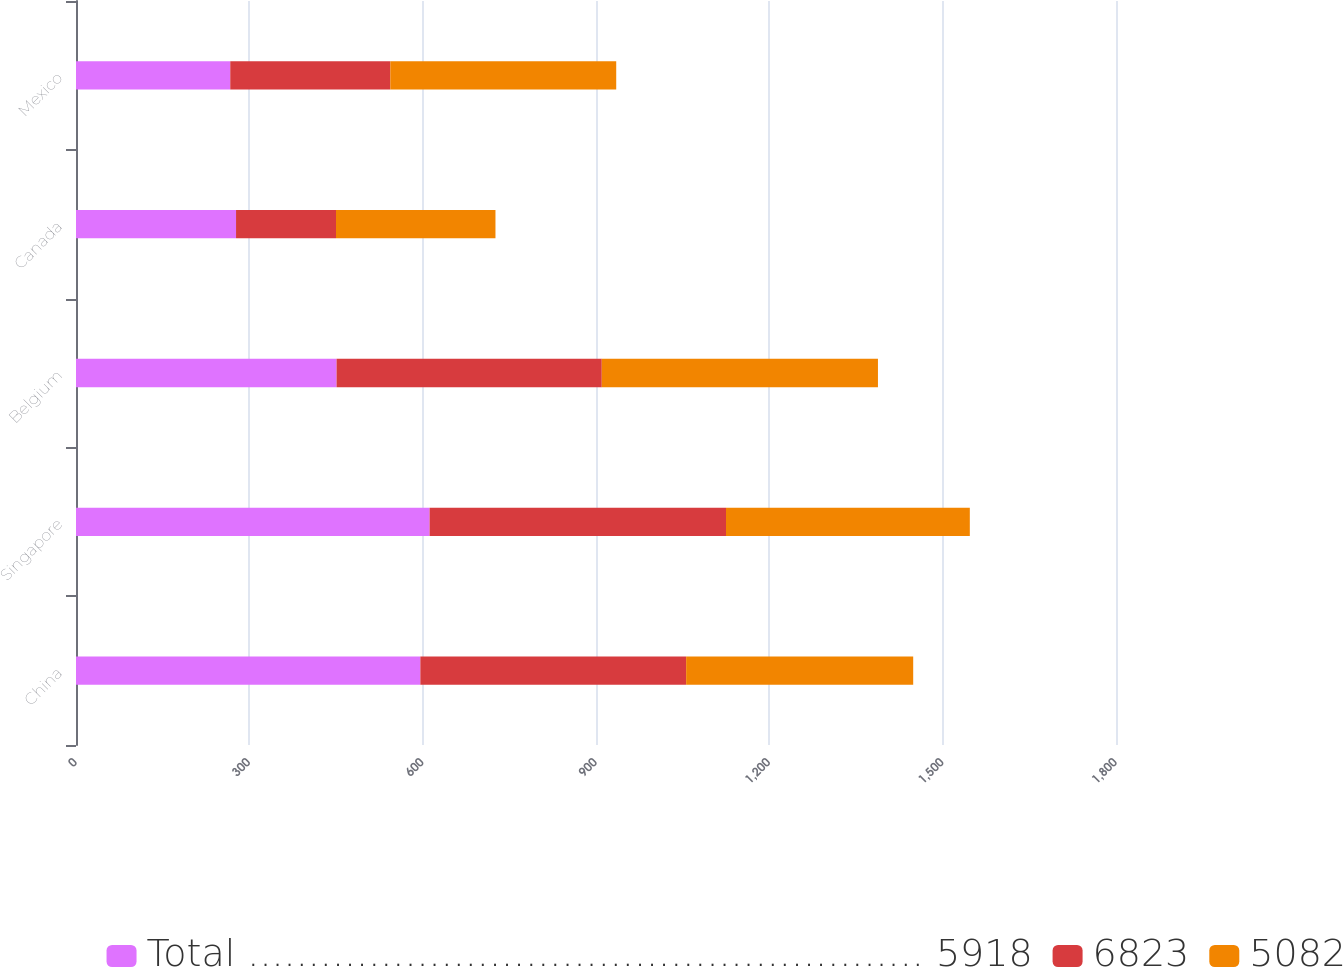Convert chart. <chart><loc_0><loc_0><loc_500><loc_500><stacked_bar_chart><ecel><fcel>China<fcel>Singapore<fcel>Belgium<fcel>Canada<fcel>Mexico<nl><fcel>Total ........................................................ 5918<fcel>596<fcel>612<fcel>451<fcel>277<fcel>267<nl><fcel>6823<fcel>460<fcel>513<fcel>459<fcel>173<fcel>277<nl><fcel>5082<fcel>393<fcel>422<fcel>478<fcel>276<fcel>391<nl></chart> 